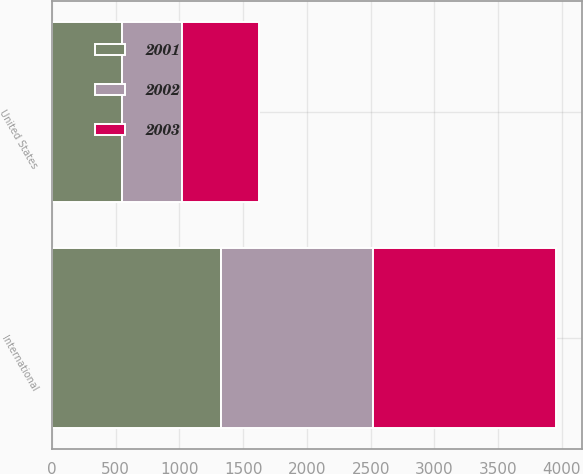Convert chart to OTSL. <chart><loc_0><loc_0><loc_500><loc_500><stacked_bar_chart><ecel><fcel>United States<fcel>International<nl><fcel>2003<fcel>602<fcel>1439.9<nl><fcel>2001<fcel>548.4<fcel>1321.9<nl><fcel>2002<fcel>474.5<fcel>1194.2<nl></chart> 